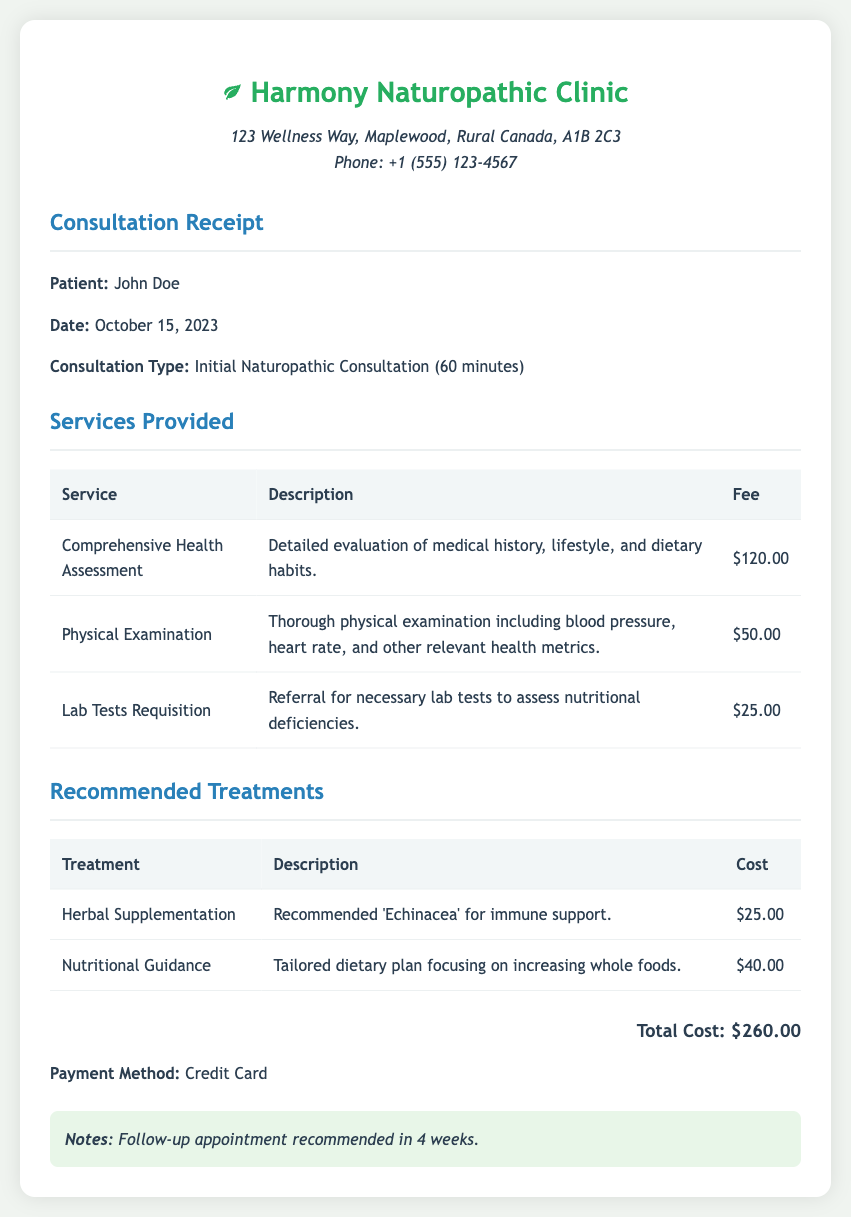What is the patient's name? The patient's name is mentioned at the beginning of the receipt.
Answer: John Doe What date was the consultation? The date is clearly stated in the document under the consultation section.
Answer: October 15, 2023 What is the total cost of the services? The total cost is summarized at the bottom of the receipt.
Answer: $260.00 How long was the consultation? The duration of the consultation is listed in the consultation type section.
Answer: 60 minutes What herbal supplement was recommended? The recommended treatment section specifies the herbal supplement.
Answer: Echinacea What service had the highest fee? By comparing the fees listed in the services table, we find the one with the highest fee.
Answer: Comprehensive Health Assessment What is the payment method used? The payment method is mentioned towards the end of the document.
Answer: Credit Card How many services were provided in total? Counting the listed services gives us the total number provided in the document.
Answer: 3 When is the recommended follow-up appointment? This information is found in the notes section of the receipt.
Answer: In 4 weeks 